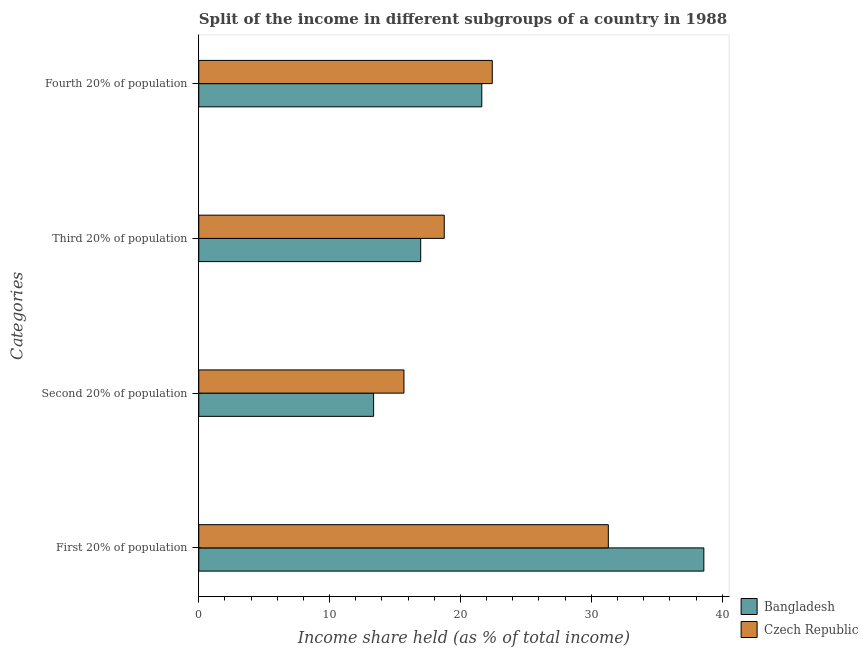How many different coloured bars are there?
Offer a very short reply. 2. Are the number of bars on each tick of the Y-axis equal?
Offer a terse response. Yes. How many bars are there on the 2nd tick from the top?
Your answer should be very brief. 2. What is the label of the 1st group of bars from the top?
Keep it short and to the point. Fourth 20% of population. What is the share of the income held by third 20% of the population in Czech Republic?
Your response must be concise. 18.76. Across all countries, what is the maximum share of the income held by fourth 20% of the population?
Offer a terse response. 22.43. Across all countries, what is the minimum share of the income held by fourth 20% of the population?
Offer a terse response. 21.63. In which country was the share of the income held by second 20% of the population maximum?
Provide a short and direct response. Czech Republic. What is the total share of the income held by first 20% of the population in the graph?
Keep it short and to the point. 69.9. What is the difference between the share of the income held by second 20% of the population in Czech Republic and that in Bangladesh?
Keep it short and to the point. 2.32. What is the difference between the share of the income held by fourth 20% of the population in Bangladesh and the share of the income held by first 20% of the population in Czech Republic?
Ensure brevity in your answer.  -9.67. What is the average share of the income held by third 20% of the population per country?
Offer a very short reply. 17.86. What is the difference between the share of the income held by third 20% of the population and share of the income held by first 20% of the population in Bangladesh?
Give a very brief answer. -21.64. In how many countries, is the share of the income held by first 20% of the population greater than 20 %?
Ensure brevity in your answer.  2. What is the ratio of the share of the income held by third 20% of the population in Czech Republic to that in Bangladesh?
Keep it short and to the point. 1.11. Is the difference between the share of the income held by fourth 20% of the population in Czech Republic and Bangladesh greater than the difference between the share of the income held by third 20% of the population in Czech Republic and Bangladesh?
Offer a very short reply. No. What is the difference between the highest and the second highest share of the income held by second 20% of the population?
Ensure brevity in your answer.  2.32. What is the difference between the highest and the lowest share of the income held by third 20% of the population?
Keep it short and to the point. 1.8. In how many countries, is the share of the income held by fourth 20% of the population greater than the average share of the income held by fourth 20% of the population taken over all countries?
Your answer should be compact. 1. What does the 2nd bar from the top in Fourth 20% of population represents?
Your answer should be very brief. Bangladesh. What does the 2nd bar from the bottom in First 20% of population represents?
Ensure brevity in your answer.  Czech Republic. Are all the bars in the graph horizontal?
Provide a succinct answer. Yes. Are the values on the major ticks of X-axis written in scientific E-notation?
Provide a succinct answer. No. How many legend labels are there?
Offer a terse response. 2. How are the legend labels stacked?
Keep it short and to the point. Vertical. What is the title of the graph?
Your response must be concise. Split of the income in different subgroups of a country in 1988. What is the label or title of the X-axis?
Offer a very short reply. Income share held (as % of total income). What is the label or title of the Y-axis?
Offer a very short reply. Categories. What is the Income share held (as % of total income) of Bangladesh in First 20% of population?
Your response must be concise. 38.6. What is the Income share held (as % of total income) of Czech Republic in First 20% of population?
Offer a very short reply. 31.3. What is the Income share held (as % of total income) of Bangladesh in Second 20% of population?
Make the answer very short. 13.36. What is the Income share held (as % of total income) of Czech Republic in Second 20% of population?
Your answer should be very brief. 15.68. What is the Income share held (as % of total income) in Bangladesh in Third 20% of population?
Make the answer very short. 16.96. What is the Income share held (as % of total income) in Czech Republic in Third 20% of population?
Your answer should be very brief. 18.76. What is the Income share held (as % of total income) of Bangladesh in Fourth 20% of population?
Provide a short and direct response. 21.63. What is the Income share held (as % of total income) of Czech Republic in Fourth 20% of population?
Offer a terse response. 22.43. Across all Categories, what is the maximum Income share held (as % of total income) of Bangladesh?
Provide a short and direct response. 38.6. Across all Categories, what is the maximum Income share held (as % of total income) in Czech Republic?
Give a very brief answer. 31.3. Across all Categories, what is the minimum Income share held (as % of total income) in Bangladesh?
Your response must be concise. 13.36. Across all Categories, what is the minimum Income share held (as % of total income) in Czech Republic?
Your answer should be very brief. 15.68. What is the total Income share held (as % of total income) of Bangladesh in the graph?
Provide a succinct answer. 90.55. What is the total Income share held (as % of total income) in Czech Republic in the graph?
Provide a succinct answer. 88.17. What is the difference between the Income share held (as % of total income) in Bangladesh in First 20% of population and that in Second 20% of population?
Give a very brief answer. 25.24. What is the difference between the Income share held (as % of total income) in Czech Republic in First 20% of population and that in Second 20% of population?
Make the answer very short. 15.62. What is the difference between the Income share held (as % of total income) in Bangladesh in First 20% of population and that in Third 20% of population?
Provide a succinct answer. 21.64. What is the difference between the Income share held (as % of total income) of Czech Republic in First 20% of population and that in Third 20% of population?
Provide a short and direct response. 12.54. What is the difference between the Income share held (as % of total income) in Bangladesh in First 20% of population and that in Fourth 20% of population?
Provide a succinct answer. 16.97. What is the difference between the Income share held (as % of total income) in Czech Republic in First 20% of population and that in Fourth 20% of population?
Make the answer very short. 8.87. What is the difference between the Income share held (as % of total income) in Czech Republic in Second 20% of population and that in Third 20% of population?
Your answer should be compact. -3.08. What is the difference between the Income share held (as % of total income) of Bangladesh in Second 20% of population and that in Fourth 20% of population?
Your answer should be compact. -8.27. What is the difference between the Income share held (as % of total income) in Czech Republic in Second 20% of population and that in Fourth 20% of population?
Offer a terse response. -6.75. What is the difference between the Income share held (as % of total income) of Bangladesh in Third 20% of population and that in Fourth 20% of population?
Your response must be concise. -4.67. What is the difference between the Income share held (as % of total income) in Czech Republic in Third 20% of population and that in Fourth 20% of population?
Keep it short and to the point. -3.67. What is the difference between the Income share held (as % of total income) of Bangladesh in First 20% of population and the Income share held (as % of total income) of Czech Republic in Second 20% of population?
Offer a terse response. 22.92. What is the difference between the Income share held (as % of total income) in Bangladesh in First 20% of population and the Income share held (as % of total income) in Czech Republic in Third 20% of population?
Your answer should be compact. 19.84. What is the difference between the Income share held (as % of total income) in Bangladesh in First 20% of population and the Income share held (as % of total income) in Czech Republic in Fourth 20% of population?
Provide a succinct answer. 16.17. What is the difference between the Income share held (as % of total income) in Bangladesh in Second 20% of population and the Income share held (as % of total income) in Czech Republic in Third 20% of population?
Offer a terse response. -5.4. What is the difference between the Income share held (as % of total income) of Bangladesh in Second 20% of population and the Income share held (as % of total income) of Czech Republic in Fourth 20% of population?
Offer a terse response. -9.07. What is the difference between the Income share held (as % of total income) in Bangladesh in Third 20% of population and the Income share held (as % of total income) in Czech Republic in Fourth 20% of population?
Provide a succinct answer. -5.47. What is the average Income share held (as % of total income) of Bangladesh per Categories?
Give a very brief answer. 22.64. What is the average Income share held (as % of total income) of Czech Republic per Categories?
Keep it short and to the point. 22.04. What is the difference between the Income share held (as % of total income) in Bangladesh and Income share held (as % of total income) in Czech Republic in Second 20% of population?
Provide a short and direct response. -2.32. What is the difference between the Income share held (as % of total income) of Bangladesh and Income share held (as % of total income) of Czech Republic in Fourth 20% of population?
Give a very brief answer. -0.8. What is the ratio of the Income share held (as % of total income) in Bangladesh in First 20% of population to that in Second 20% of population?
Your response must be concise. 2.89. What is the ratio of the Income share held (as % of total income) in Czech Republic in First 20% of population to that in Second 20% of population?
Make the answer very short. 2. What is the ratio of the Income share held (as % of total income) in Bangladesh in First 20% of population to that in Third 20% of population?
Your answer should be very brief. 2.28. What is the ratio of the Income share held (as % of total income) in Czech Republic in First 20% of population to that in Third 20% of population?
Offer a very short reply. 1.67. What is the ratio of the Income share held (as % of total income) of Bangladesh in First 20% of population to that in Fourth 20% of population?
Ensure brevity in your answer.  1.78. What is the ratio of the Income share held (as % of total income) of Czech Republic in First 20% of population to that in Fourth 20% of population?
Provide a short and direct response. 1.4. What is the ratio of the Income share held (as % of total income) of Bangladesh in Second 20% of population to that in Third 20% of population?
Your answer should be compact. 0.79. What is the ratio of the Income share held (as % of total income) of Czech Republic in Second 20% of population to that in Third 20% of population?
Give a very brief answer. 0.84. What is the ratio of the Income share held (as % of total income) in Bangladesh in Second 20% of population to that in Fourth 20% of population?
Make the answer very short. 0.62. What is the ratio of the Income share held (as % of total income) of Czech Republic in Second 20% of population to that in Fourth 20% of population?
Keep it short and to the point. 0.7. What is the ratio of the Income share held (as % of total income) in Bangladesh in Third 20% of population to that in Fourth 20% of population?
Your answer should be compact. 0.78. What is the ratio of the Income share held (as % of total income) in Czech Republic in Third 20% of population to that in Fourth 20% of population?
Your response must be concise. 0.84. What is the difference between the highest and the second highest Income share held (as % of total income) in Bangladesh?
Your response must be concise. 16.97. What is the difference between the highest and the second highest Income share held (as % of total income) of Czech Republic?
Offer a very short reply. 8.87. What is the difference between the highest and the lowest Income share held (as % of total income) of Bangladesh?
Give a very brief answer. 25.24. What is the difference between the highest and the lowest Income share held (as % of total income) of Czech Republic?
Make the answer very short. 15.62. 